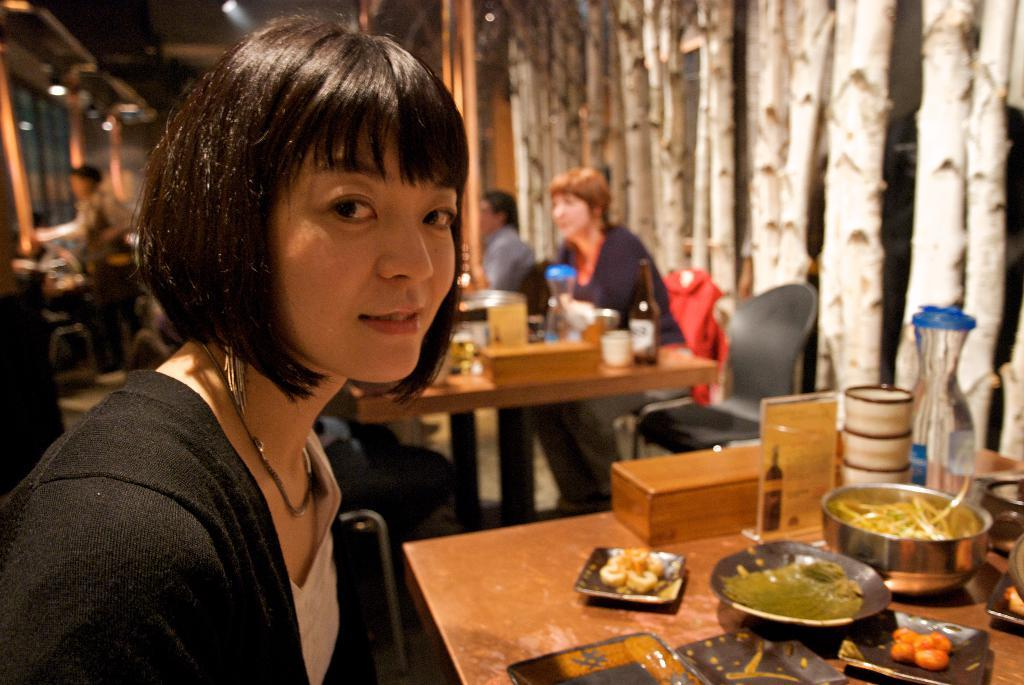What are the people in the image doing? The people in the image are sitting. Where are the people sitting in relation to the tables? The people are sitting in front of the tables. What can be seen on the tables in the image? There are objects placed on the tables. How many people are involved in the argument in the image? There is no argument present in the image; it shows people sitting in front of tables with objects on them. 